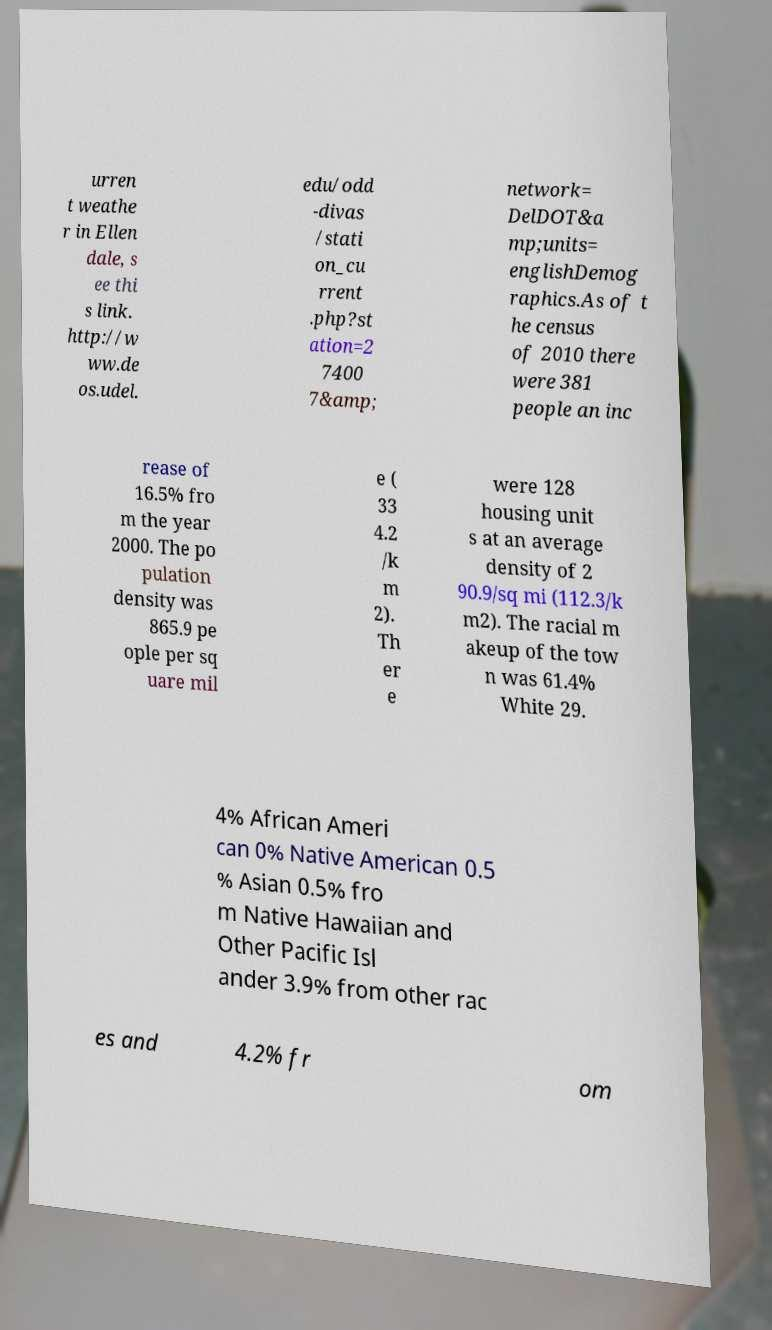Please read and relay the text visible in this image. What does it say? urren t weathe r in Ellen dale, s ee thi s link. http://w ww.de os.udel. edu/odd -divas /stati on_cu rrent .php?st ation=2 7400 7&amp; network= DelDOT&a mp;units= englishDemog raphics.As of t he census of 2010 there were 381 people an inc rease of 16.5% fro m the year 2000. The po pulation density was 865.9 pe ople per sq uare mil e ( 33 4.2 /k m 2). Th er e were 128 housing unit s at an average density of 2 90.9/sq mi (112.3/k m2). The racial m akeup of the tow n was 61.4% White 29. 4% African Ameri can 0% Native American 0.5 % Asian 0.5% fro m Native Hawaiian and Other Pacific Isl ander 3.9% from other rac es and 4.2% fr om 